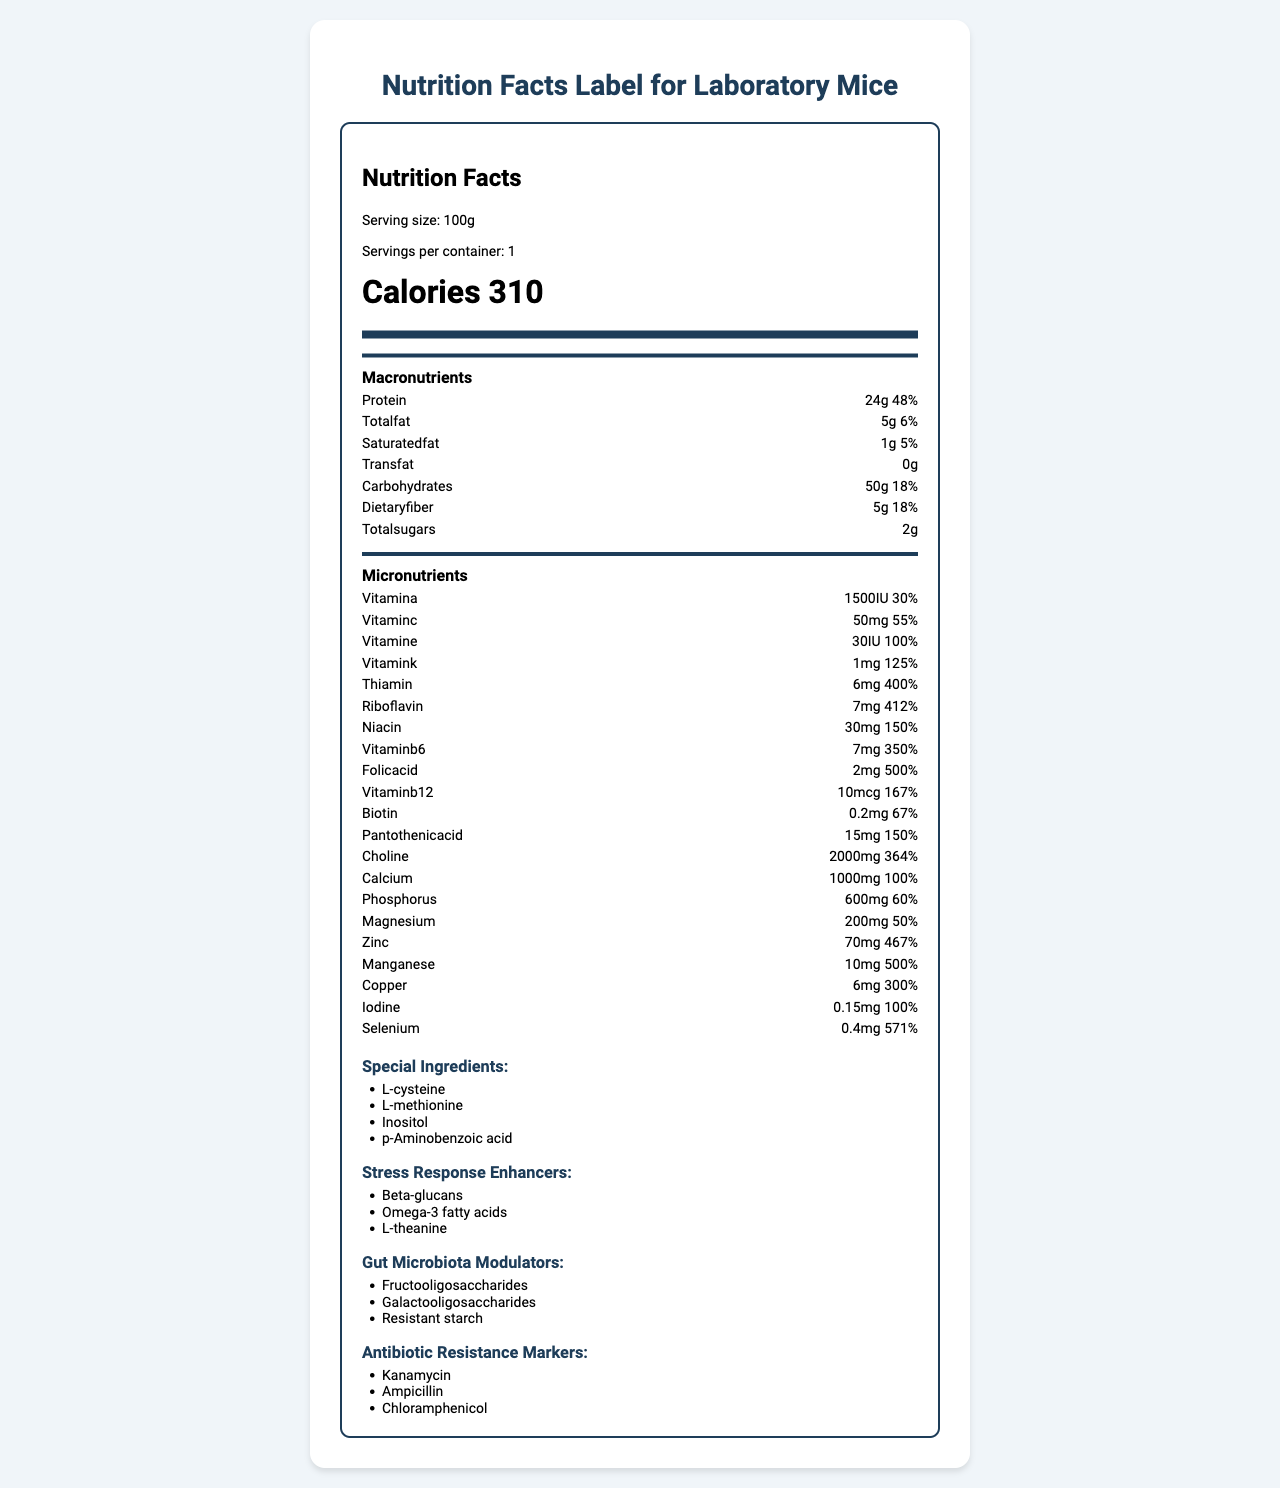what is the serving size? The serving size is mentioned in the "Serving size" field.
Answer: 100g how many calories are there per serving? The calories per serving are explicitly written as 310.
Answer: 310 calories what is the amount of protein per serving? The label states that there are 24g of protein per serving in the macronutrients section.
Answer: 24g what special ingredients are included in the diet? The special ingredients are listed under the "Special Ingredients" section in the additional info.
Answer: L-cysteine, L-methionine, Inositol, p-Aminobenzoic acid how does the amount of dietary fiber compare to total sugars? The document states that there are 5g of dietary fiber and 2g of total sugars per serving.
Answer: 5g dietary fiber, 2g total sugars what percentage of daily value of zinc does this diet provide? The micronutrients section indicates that the diet provides 467% of the daily value for zinc.
Answer: 467% which of the following vitamins has the highest percent daily value? A. Vitamin A B. Vitamin C C. Vitamin E D. Vitamin B6 Vitamin B6 has a percent daily value of 350%, which is higher than that of vitamins A (30%), C (55%), and E (100%).
Answer: D. Vitamin B6 which micronutrient is provided in a 2 mg amount? A. Folic Acid B. B12 C. Pantothenic Acid D. Riboflavin The micronutrients section shows that Folic Acid is provided in a 2 mg amount.
Answer: A. Folic Acid does this diet contain any trans fat? The document explicitly states 0g for trans fat under macronutrients.
Answer: No summarize the content of this document. The explanation is that the document provides comprehensive nutritional details about the diet, including several types of ingredients aimed at enhancing stress response, modulating gut microbiota, and containing antibiotic resistance markers.
Answer: The document is a nutrition facts label for a specialized laboratory mice diet used in bacterial genetic studies. It includes detailed information on serving size, calories, macronutrient breakdown, and micronutrient content, along with special ingredients, stress response enhancers, gut microbiota modulators, and antibiotic resistance markers. which bacterium is being studied with this diet? The document does not provide information about which specific bacterium is being studied.
Answer: Cannot be determined 